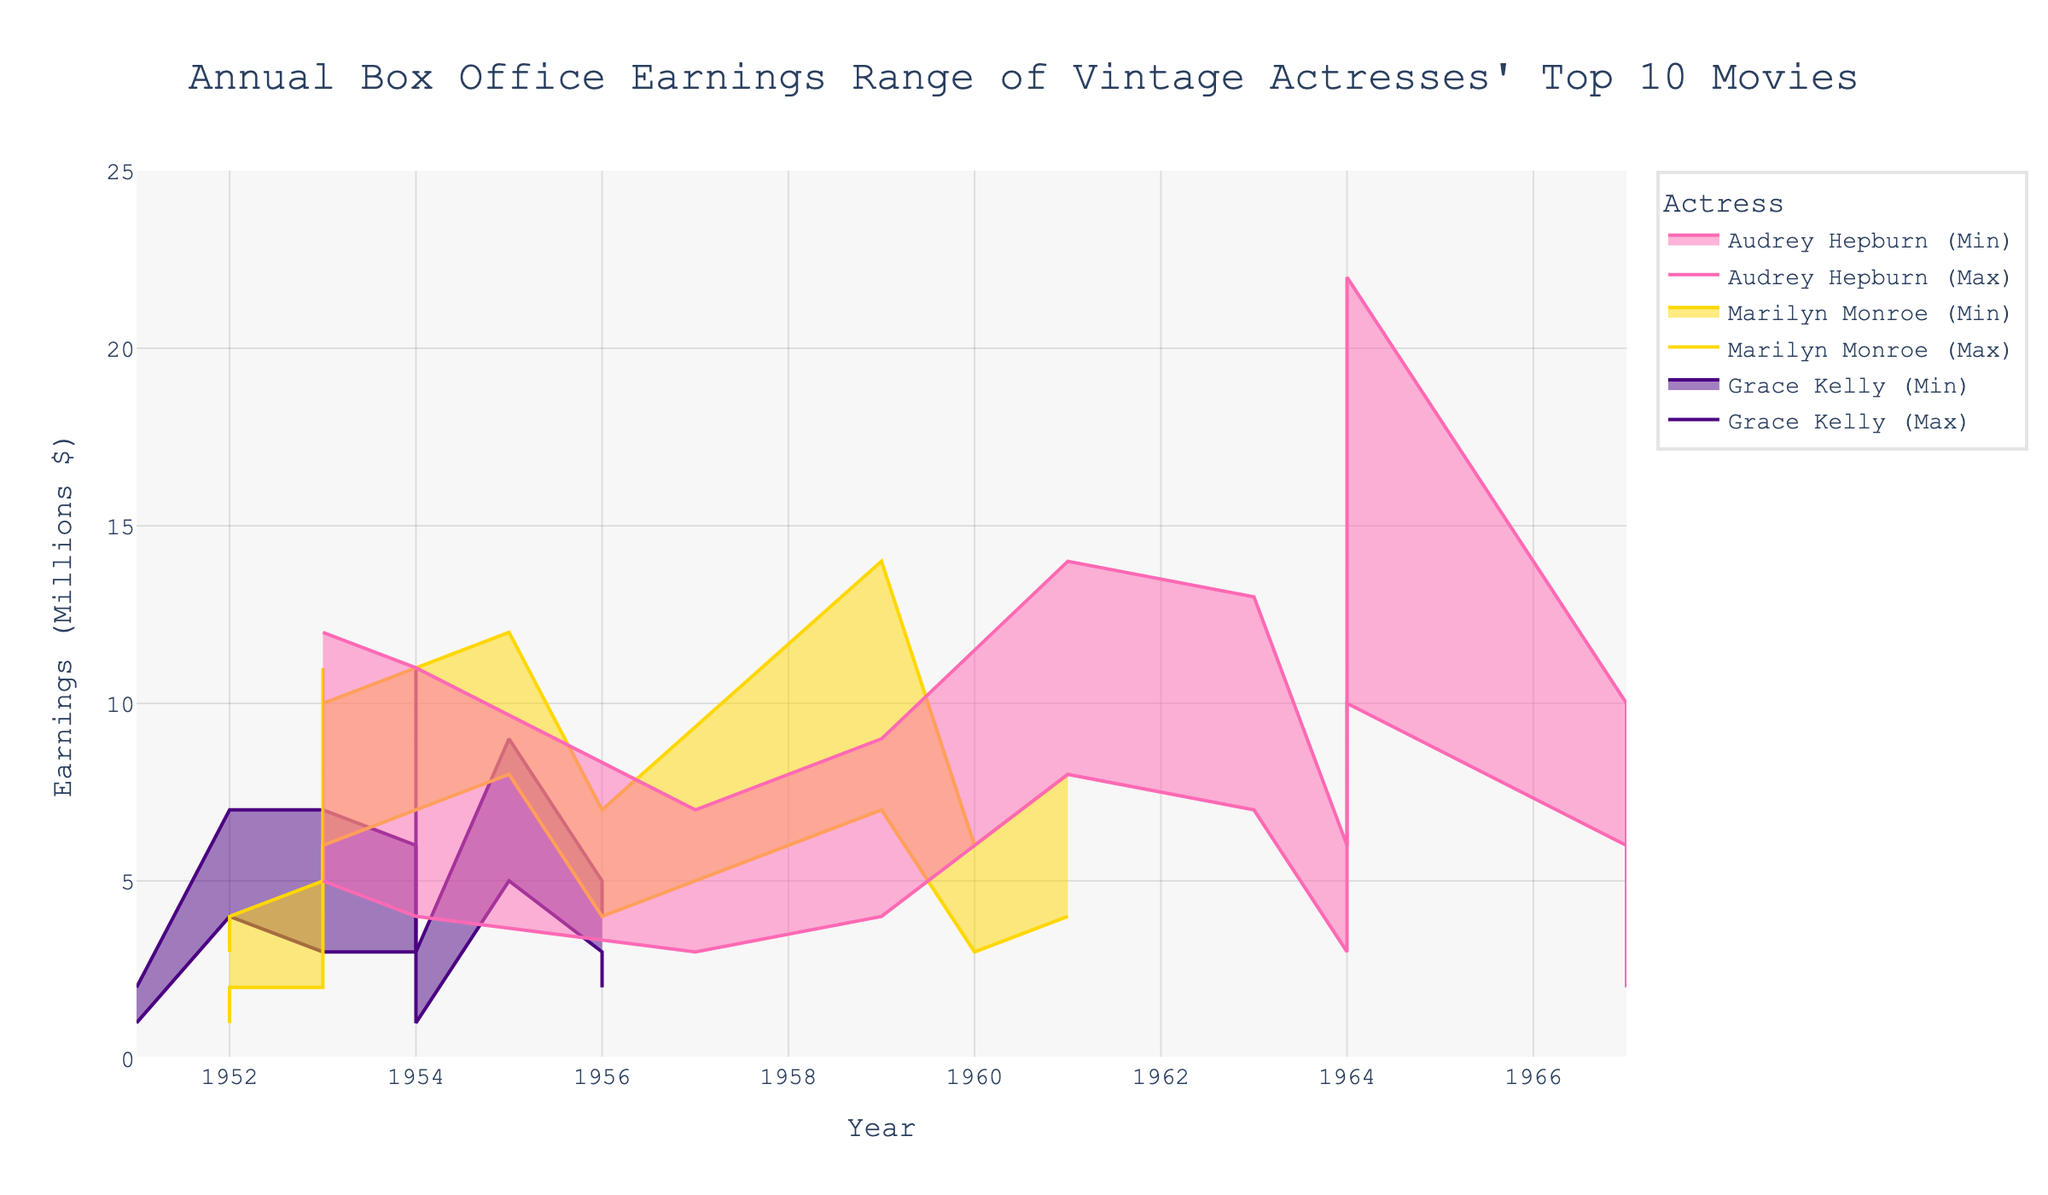What is the highest maximum box office earning among Audrey Hepburn's movies? Look for the highest value on the upper boundary of Audrey Hepburn's earning lines. The highest point in the range area chart for her movies is 22 million dollars in "My Fair Lady" (1964).
Answer: 22 million What are the minimum and maximum earnings ranges for "Some Like It Hot" by Marilyn Monroe? Identify the minimum and maximum earnings for "Some Like It Hot" by locating the respective markers in the visual for the year 1959. This movie has a minimum earning of 7 million and a maximum earning of 14 million dollars.
Answer: 7 million, 14 million Which actress had the lowest maximum box office earning and what was it? Examine the top lines (maximum earnings) for all actresses. Grace Kelly's movies, with the highest maximum being 11 million dollars, show the lowest peak compared to the highest earnings of other actresses.
Answer: Grace Kelly, 11 million Which movie brought Audrey Hepburn the lowest maximum earnings, and how much was it? Look for the lowest point on the upper earnings boundary for Audrey Hepburn’s movies. "Two for the Road" (1967) shows the lowest maximum earnings at 5 million dollars.
Answer: Two for the Road, 5 million For which movies did Marilyn Monroe have earnings between 5 million and 10 million dollars? Find Marilyn Monroe's movies that have a minimum and maximum earnings range within 5 to 10 million dollars. "Gentlemen Prefer Blondes" (1953) and "How to Marry a Millionaire" (1953) fall within this earnings range, considering both their minimum and maximum values.
Answer: Gentlemen Prefer Blondes, How to Marry a Millionaire How does the earnings range of "Rear Window" (1954) by Grace Kelly compare to "Roman Holiday" (1953) by Audrey Hepburn? Compare the earnings ranges by looking at the vertical spans for these movies in the given years. "Rear Window" has earnings ranging from 6 to 11 million, whereas "Roman Holiday" has a range from 5 to 12 million dollars. Therefore, Audrey Hepburn's movie shows a wider range and a higher maximum earning than Grace Kelly’s movie.
Answer: Roman Holiday has a wider range and higher maximum What is the average maximum earnings among Marilyn Monroe's movies? Sum the maximum earnings of all Marilyn Monroe’s movies and divide by the number of her movies: (14 + 10 + 12 + 11 + 8 + 7 + 5 + 6 + 4 + 3) / 10 to get an average. The total is 80, so the average maximum earnings is 8 million dollars.
Answer: 8 million Which actress had the highest revenue in a single year and what was the year? Look for the highest single point in earnings over the entire chart across all actresses. Audrey Hepburn's "My Fair Lady" (1964) had the highest peak with 22 million dollars.
Answer: Audrey Hepburn, 1964 Grace Kelly has two movies in 1954. What are the maximum and minimum earnings combined for those movies? Identify and sum the maximum earnings for "Dial M for Murder" and "Green Fire" and do the same for the minimum. The combined maximum is (5 + 11) = 16 million, and combined minimum is (2 + 1) = 3 million dollars.
Answer: Max: 16 million, Min: 3 million 